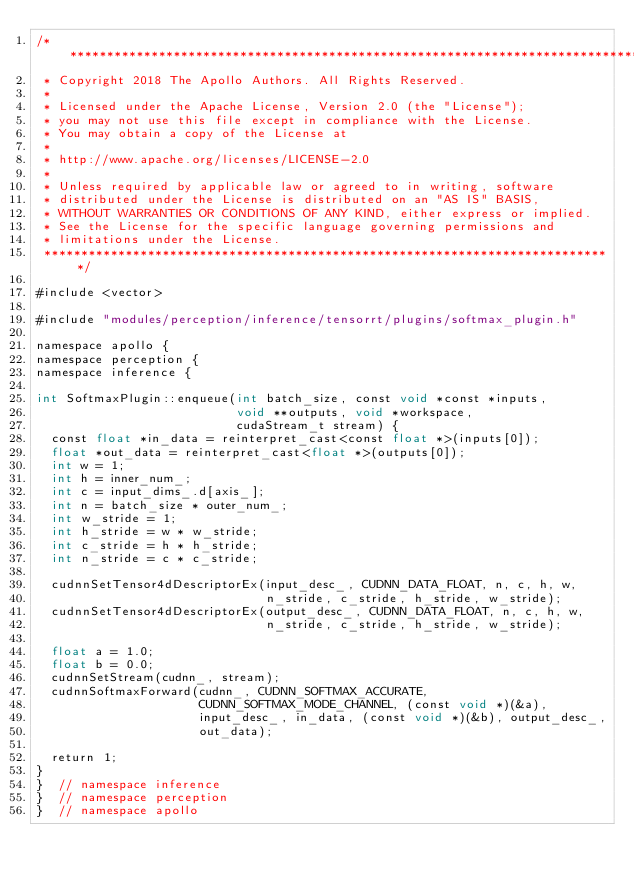<code> <loc_0><loc_0><loc_500><loc_500><_Cuda_>/******************************************************************************
 * Copyright 2018 The Apollo Authors. All Rights Reserved.
 *
 * Licensed under the Apache License, Version 2.0 (the "License");
 * you may not use this file except in compliance with the License.
 * You may obtain a copy of the License at
 *
 * http://www.apache.org/licenses/LICENSE-2.0
 *
 * Unless required by applicable law or agreed to in writing, software
 * distributed under the License is distributed on an "AS IS" BASIS,
 * WITHOUT WARRANTIES OR CONDITIONS OF ANY KIND, either express or implied.
 * See the License for the specific language governing permissions and
 * limitations under the License.
 *****************************************************************************/

#include <vector>

#include "modules/perception/inference/tensorrt/plugins/softmax_plugin.h"

namespace apollo {
namespace perception {
namespace inference {

int SoftmaxPlugin::enqueue(int batch_size, const void *const *inputs,
                           void **outputs, void *workspace,
                           cudaStream_t stream) {
  const float *in_data = reinterpret_cast<const float *>(inputs[0]);
  float *out_data = reinterpret_cast<float *>(outputs[0]);
  int w = 1;
  int h = inner_num_;
  int c = input_dims_.d[axis_];
  int n = batch_size * outer_num_;
  int w_stride = 1;
  int h_stride = w * w_stride;
  int c_stride = h * h_stride;
  int n_stride = c * c_stride;

  cudnnSetTensor4dDescriptorEx(input_desc_, CUDNN_DATA_FLOAT, n, c, h, w,
                               n_stride, c_stride, h_stride, w_stride);
  cudnnSetTensor4dDescriptorEx(output_desc_, CUDNN_DATA_FLOAT, n, c, h, w,
                               n_stride, c_stride, h_stride, w_stride);

  float a = 1.0;
  float b = 0.0;
  cudnnSetStream(cudnn_, stream);
  cudnnSoftmaxForward(cudnn_, CUDNN_SOFTMAX_ACCURATE,
                      CUDNN_SOFTMAX_MODE_CHANNEL, (const void *)(&a),
                      input_desc_, in_data, (const void *)(&b), output_desc_,
                      out_data);

  return 1;
}
}  // namespace inference
}  // namespace perception
}  // namespace apollo
</code> 